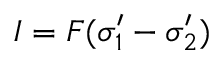<formula> <loc_0><loc_0><loc_500><loc_500>I = F ( \sigma _ { 1 } ^ { \prime } - \sigma _ { 2 } ^ { \prime } )</formula> 